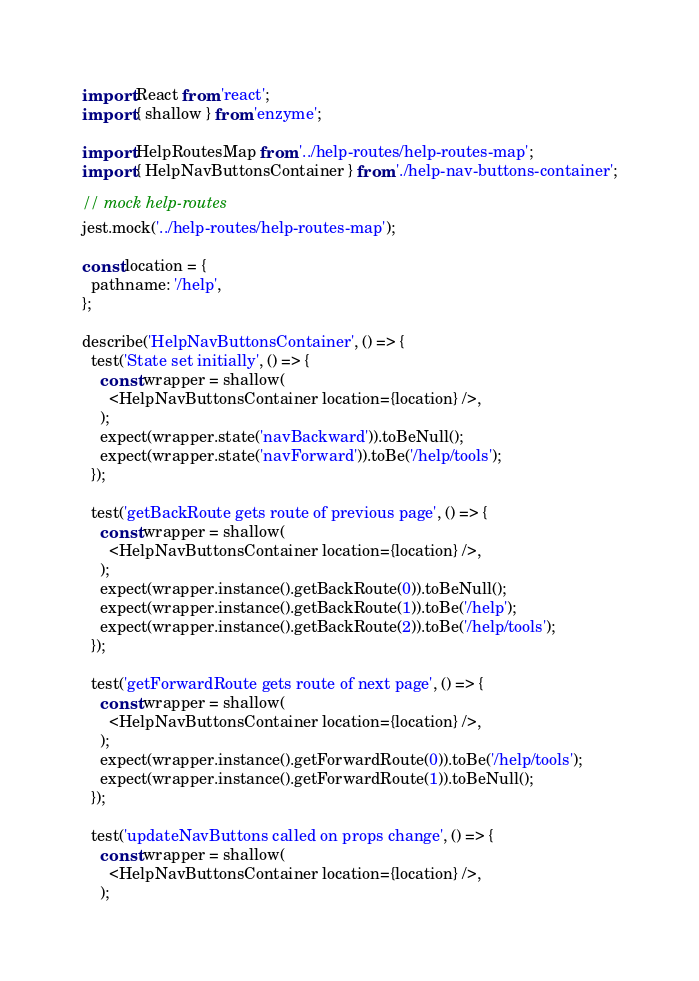Convert code to text. <code><loc_0><loc_0><loc_500><loc_500><_JavaScript_>import React from 'react';
import { shallow } from 'enzyme';

import HelpRoutesMap from '../help-routes/help-routes-map';
import { HelpNavButtonsContainer } from './help-nav-buttons-container';

// mock help-routes
jest.mock('../help-routes/help-routes-map');

const location = {
  pathname: '/help',
};

describe('HelpNavButtonsContainer', () => {
  test('State set initially', () => {
    const wrapper = shallow(
      <HelpNavButtonsContainer location={location} />,
    );
    expect(wrapper.state('navBackward')).toBeNull();
    expect(wrapper.state('navForward')).toBe('/help/tools');
  });

  test('getBackRoute gets route of previous page', () => {
    const wrapper = shallow(
      <HelpNavButtonsContainer location={location} />,
    );
    expect(wrapper.instance().getBackRoute(0)).toBeNull();
    expect(wrapper.instance().getBackRoute(1)).toBe('/help');
    expect(wrapper.instance().getBackRoute(2)).toBe('/help/tools');
  });

  test('getForwardRoute gets route of next page', () => {
    const wrapper = shallow(
      <HelpNavButtonsContainer location={location} />,
    );
    expect(wrapper.instance().getForwardRoute(0)).toBe('/help/tools');
    expect(wrapper.instance().getForwardRoute(1)).toBeNull();
  });

  test('updateNavButtons called on props change', () => {
    const wrapper = shallow(
      <HelpNavButtonsContainer location={location} />,
    );</code> 